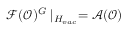Convert formula to latex. <formula><loc_0><loc_0><loc_500><loc_500>\mathcal { F } ( \mathcal { O } ) ^ { G } | _ { H _ { v a c } } = \mathcal { A ( O ) }</formula> 